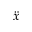<formula> <loc_0><loc_0><loc_500><loc_500>\ddot { x }</formula> 